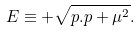<formula> <loc_0><loc_0><loc_500><loc_500>E \equiv + \sqrt { p . p + \mu ^ { 2 } } .</formula> 